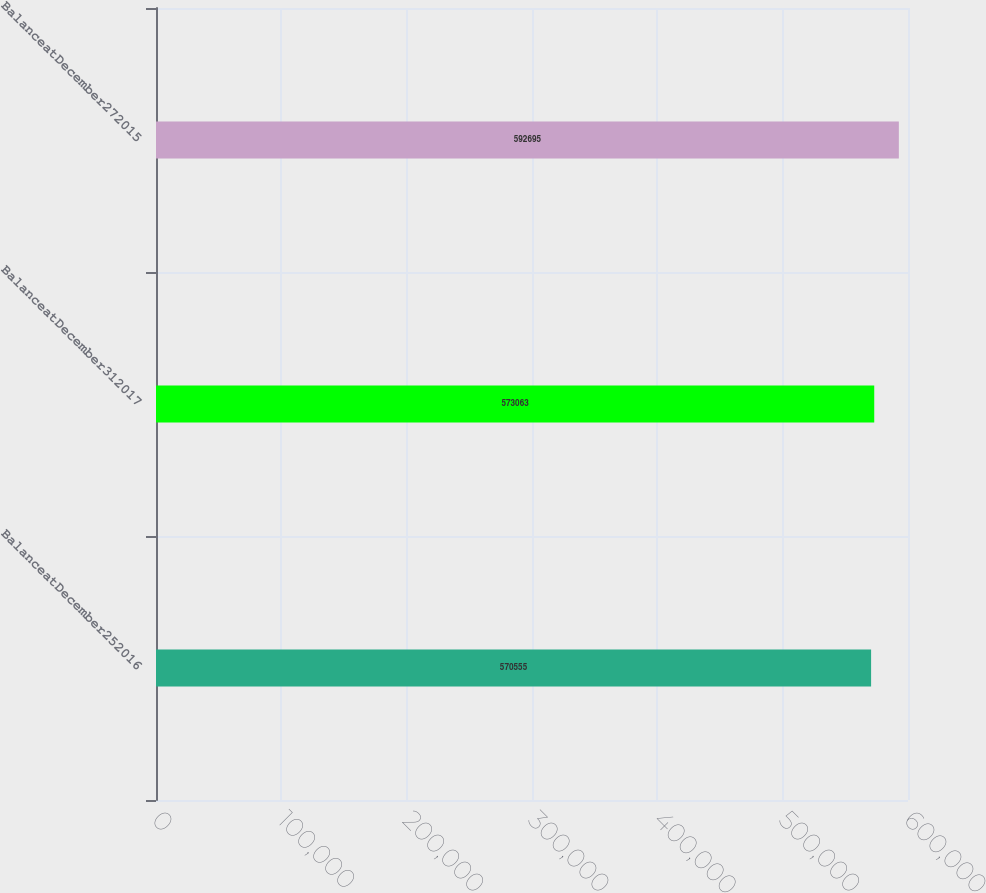<chart> <loc_0><loc_0><loc_500><loc_500><bar_chart><fcel>BalanceatDecember252016<fcel>BalanceatDecember312017<fcel>BalanceatDecember272015<nl><fcel>570555<fcel>573063<fcel>592695<nl></chart> 